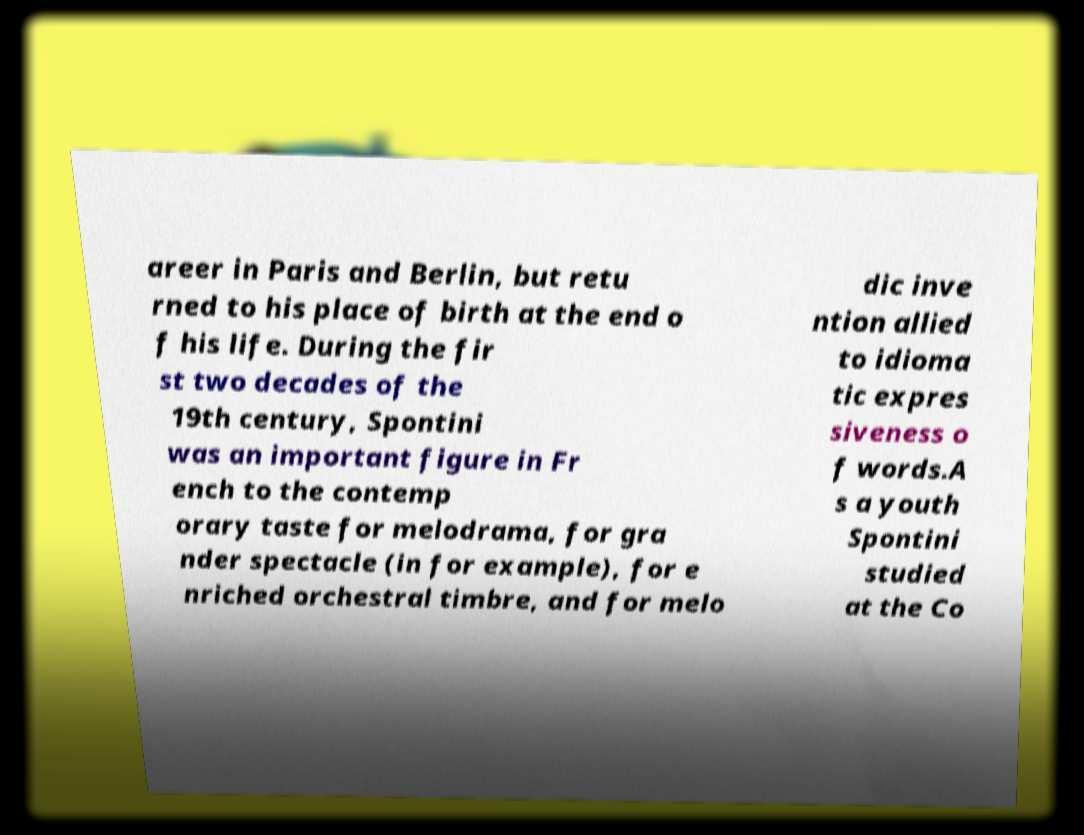Please read and relay the text visible in this image. What does it say? areer in Paris and Berlin, but retu rned to his place of birth at the end o f his life. During the fir st two decades of the 19th century, Spontini was an important figure in Fr ench to the contemp orary taste for melodrama, for gra nder spectacle (in for example), for e nriched orchestral timbre, and for melo dic inve ntion allied to idioma tic expres siveness o f words.A s a youth Spontini studied at the Co 